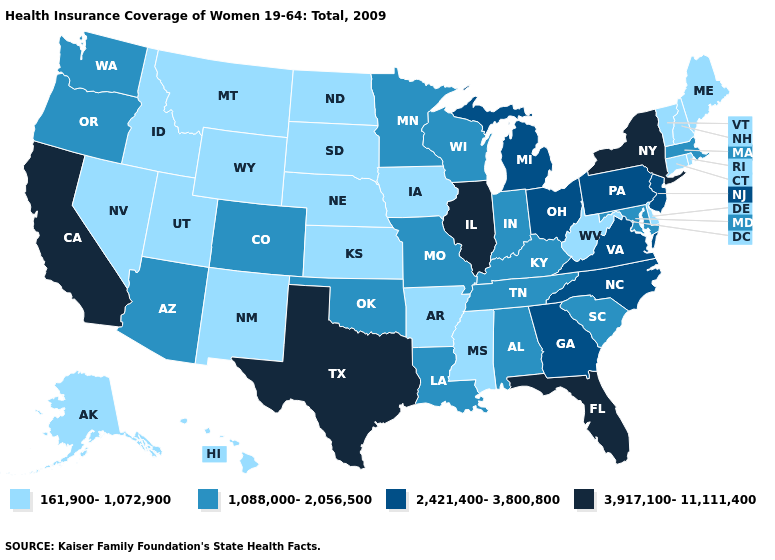Does Texas have the highest value in the South?
Concise answer only. Yes. Name the states that have a value in the range 1,088,000-2,056,500?
Keep it brief. Alabama, Arizona, Colorado, Indiana, Kentucky, Louisiana, Maryland, Massachusetts, Minnesota, Missouri, Oklahoma, Oregon, South Carolina, Tennessee, Washington, Wisconsin. What is the value of Nevada?
Short answer required. 161,900-1,072,900. Which states have the lowest value in the South?
Be succinct. Arkansas, Delaware, Mississippi, West Virginia. What is the value of Connecticut?
Quick response, please. 161,900-1,072,900. What is the value of Arkansas?
Answer briefly. 161,900-1,072,900. What is the value of Washington?
Be succinct. 1,088,000-2,056,500. What is the lowest value in the USA?
Answer briefly. 161,900-1,072,900. Name the states that have a value in the range 2,421,400-3,800,800?
Short answer required. Georgia, Michigan, New Jersey, North Carolina, Ohio, Pennsylvania, Virginia. What is the value of Alaska?
Quick response, please. 161,900-1,072,900. Does Delaware have the lowest value in the USA?
Short answer required. Yes. What is the value of Louisiana?
Concise answer only. 1,088,000-2,056,500. Name the states that have a value in the range 3,917,100-11,111,400?
Write a very short answer. California, Florida, Illinois, New York, Texas. What is the lowest value in states that border Mississippi?
Concise answer only. 161,900-1,072,900. Which states have the lowest value in the USA?
Keep it brief. Alaska, Arkansas, Connecticut, Delaware, Hawaii, Idaho, Iowa, Kansas, Maine, Mississippi, Montana, Nebraska, Nevada, New Hampshire, New Mexico, North Dakota, Rhode Island, South Dakota, Utah, Vermont, West Virginia, Wyoming. 